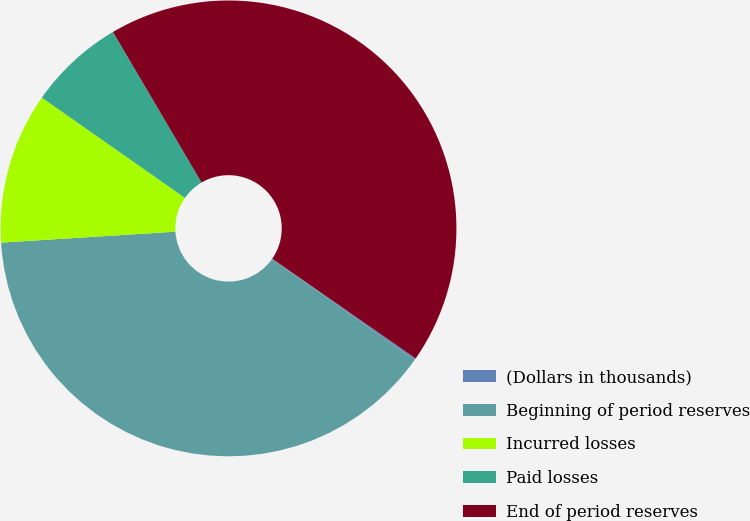Convert chart. <chart><loc_0><loc_0><loc_500><loc_500><pie_chart><fcel>(Dollars in thousands)<fcel>Beginning of period reserves<fcel>Incurred losses<fcel>Paid losses<fcel>End of period reserves<nl><fcel>0.12%<fcel>39.22%<fcel>10.72%<fcel>6.81%<fcel>43.13%<nl></chart> 